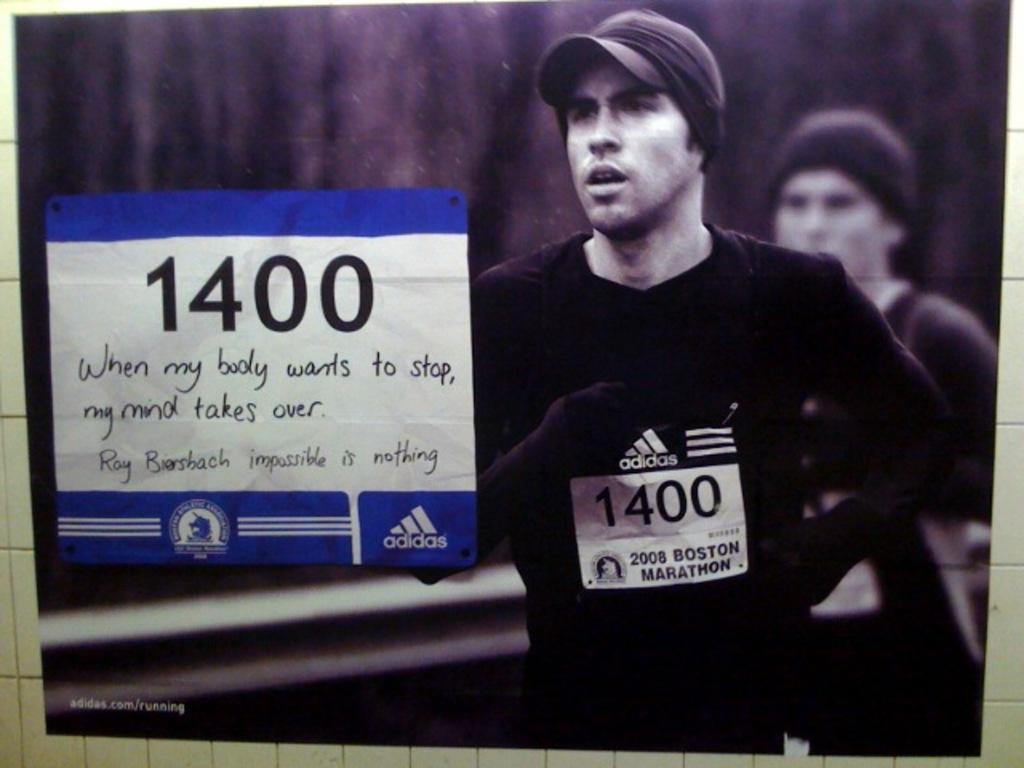Could you give a brief overview of what you see in this image? In this picture there is a board on the wall. On the board there is a picture of a person running and there is a person and there is a text. On the bottom left of the board there is a text. There are tiles on the wall. 